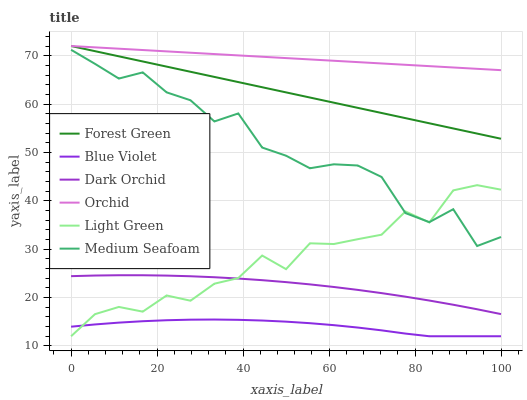Does Blue Violet have the minimum area under the curve?
Answer yes or no. Yes. Does Orchid have the maximum area under the curve?
Answer yes or no. Yes. Does Forest Green have the minimum area under the curve?
Answer yes or no. No. Does Forest Green have the maximum area under the curve?
Answer yes or no. No. Is Forest Green the smoothest?
Answer yes or no. Yes. Is Medium Seafoam the roughest?
Answer yes or no. Yes. Is Light Green the smoothest?
Answer yes or no. No. Is Light Green the roughest?
Answer yes or no. No. Does Light Green have the lowest value?
Answer yes or no. Yes. Does Forest Green have the lowest value?
Answer yes or no. No. Does Orchid have the highest value?
Answer yes or no. Yes. Does Light Green have the highest value?
Answer yes or no. No. Is Medium Seafoam less than Orchid?
Answer yes or no. Yes. Is Medium Seafoam greater than Dark Orchid?
Answer yes or no. Yes. Does Light Green intersect Dark Orchid?
Answer yes or no. Yes. Is Light Green less than Dark Orchid?
Answer yes or no. No. Is Light Green greater than Dark Orchid?
Answer yes or no. No. Does Medium Seafoam intersect Orchid?
Answer yes or no. No. 